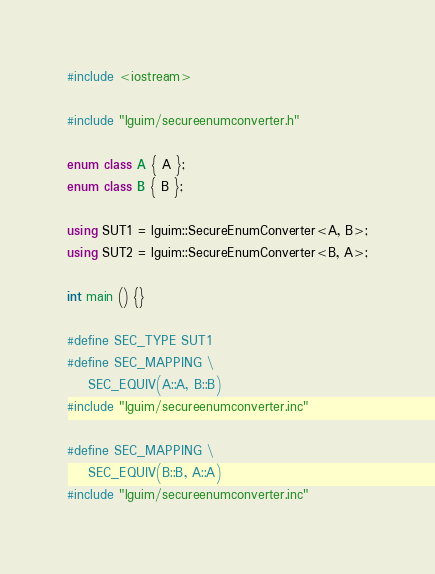<code> <loc_0><loc_0><loc_500><loc_500><_C++_>#include <iostream>

#include "lguim/secureenumconverter.h"

enum class A { A };
enum class B { B };

using SUT1 = lguim::SecureEnumConverter<A, B>;
using SUT2 = lguim::SecureEnumConverter<B, A>;

int main () {}

#define SEC_TYPE SUT1
#define SEC_MAPPING \
    SEC_EQUIV(A::A, B::B)
#include "lguim/secureenumconverter.inc"

#define SEC_MAPPING \
    SEC_EQUIV(B::B, A::A)
#include "lguim/secureenumconverter.inc"
</code> 